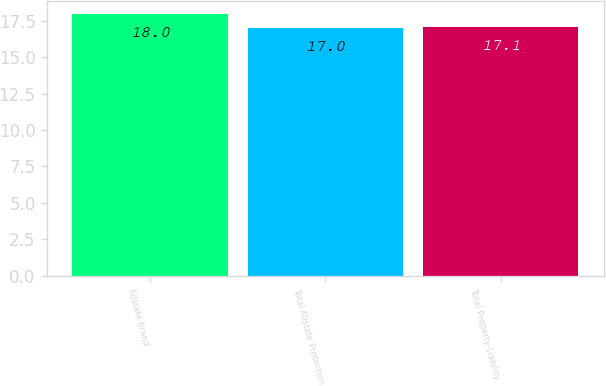<chart> <loc_0><loc_0><loc_500><loc_500><bar_chart><fcel>Allstate brand<fcel>Total Allstate Protection<fcel>Total Property-Liability<nl><fcel>18<fcel>17<fcel>17.1<nl></chart> 